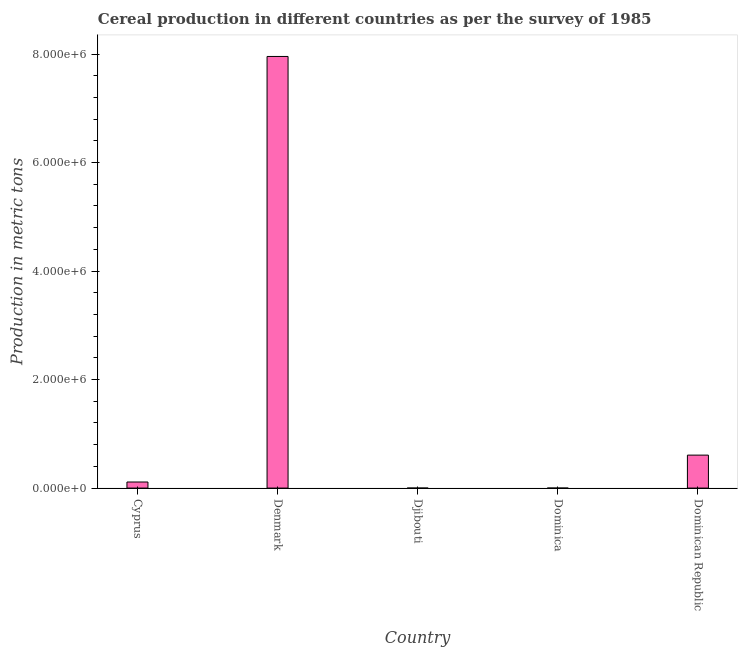What is the title of the graph?
Provide a short and direct response. Cereal production in different countries as per the survey of 1985. What is the label or title of the X-axis?
Your answer should be very brief. Country. What is the label or title of the Y-axis?
Your response must be concise. Production in metric tons. What is the cereal production in Djibouti?
Ensure brevity in your answer.  7. Across all countries, what is the maximum cereal production?
Keep it short and to the point. 7.96e+06. In which country was the cereal production maximum?
Your answer should be compact. Denmark. In which country was the cereal production minimum?
Your answer should be compact. Djibouti. What is the sum of the cereal production?
Give a very brief answer. 8.68e+06. What is the difference between the cereal production in Djibouti and Dominica?
Offer a terse response. -193. What is the average cereal production per country?
Ensure brevity in your answer.  1.74e+06. What is the median cereal production?
Keep it short and to the point. 1.12e+05. In how many countries, is the cereal production greater than 400000 metric tons?
Provide a short and direct response. 2. What is the ratio of the cereal production in Denmark to that in Djibouti?
Provide a short and direct response. 1.14e+06. Is the difference between the cereal production in Djibouti and Dominica greater than the difference between any two countries?
Provide a succinct answer. No. What is the difference between the highest and the second highest cereal production?
Ensure brevity in your answer.  7.35e+06. What is the difference between the highest and the lowest cereal production?
Offer a terse response. 7.96e+06. How many bars are there?
Make the answer very short. 5. How many countries are there in the graph?
Make the answer very short. 5. What is the difference between two consecutive major ticks on the Y-axis?
Offer a very short reply. 2.00e+06. What is the Production in metric tons in Cyprus?
Keep it short and to the point. 1.12e+05. What is the Production in metric tons of Denmark?
Your response must be concise. 7.96e+06. What is the Production in metric tons of Djibouti?
Make the answer very short. 7. What is the Production in metric tons of Dominican Republic?
Your answer should be compact. 6.08e+05. What is the difference between the Production in metric tons in Cyprus and Denmark?
Give a very brief answer. -7.84e+06. What is the difference between the Production in metric tons in Cyprus and Djibouti?
Offer a very short reply. 1.12e+05. What is the difference between the Production in metric tons in Cyprus and Dominica?
Keep it short and to the point. 1.12e+05. What is the difference between the Production in metric tons in Cyprus and Dominican Republic?
Offer a terse response. -4.96e+05. What is the difference between the Production in metric tons in Denmark and Djibouti?
Your answer should be very brief. 7.96e+06. What is the difference between the Production in metric tons in Denmark and Dominica?
Give a very brief answer. 7.96e+06. What is the difference between the Production in metric tons in Denmark and Dominican Republic?
Your answer should be compact. 7.35e+06. What is the difference between the Production in metric tons in Djibouti and Dominica?
Provide a succinct answer. -193. What is the difference between the Production in metric tons in Djibouti and Dominican Republic?
Your answer should be compact. -6.08e+05. What is the difference between the Production in metric tons in Dominica and Dominican Republic?
Make the answer very short. -6.08e+05. What is the ratio of the Production in metric tons in Cyprus to that in Denmark?
Ensure brevity in your answer.  0.01. What is the ratio of the Production in metric tons in Cyprus to that in Djibouti?
Your answer should be compact. 1.60e+04. What is the ratio of the Production in metric tons in Cyprus to that in Dominica?
Offer a terse response. 561. What is the ratio of the Production in metric tons in Cyprus to that in Dominican Republic?
Give a very brief answer. 0.18. What is the ratio of the Production in metric tons in Denmark to that in Djibouti?
Give a very brief answer. 1.14e+06. What is the ratio of the Production in metric tons in Denmark to that in Dominica?
Provide a short and direct response. 3.98e+04. What is the ratio of the Production in metric tons in Denmark to that in Dominican Republic?
Provide a short and direct response. 13.09. What is the ratio of the Production in metric tons in Djibouti to that in Dominica?
Provide a short and direct response. 0.04. What is the ratio of the Production in metric tons in Djibouti to that in Dominican Republic?
Keep it short and to the point. 0. What is the ratio of the Production in metric tons in Dominica to that in Dominican Republic?
Provide a succinct answer. 0. 